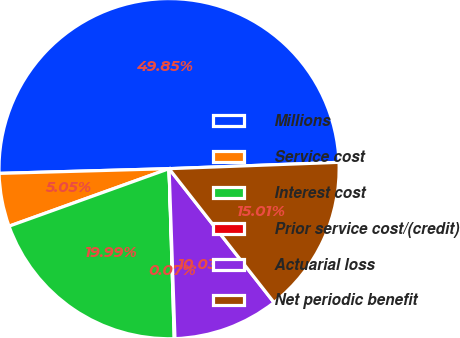Convert chart to OTSL. <chart><loc_0><loc_0><loc_500><loc_500><pie_chart><fcel>Millions<fcel>Service cost<fcel>Interest cost<fcel>Prior service cost/(credit)<fcel>Actuarial loss<fcel>Net periodic benefit<nl><fcel>49.85%<fcel>5.05%<fcel>19.99%<fcel>0.07%<fcel>10.03%<fcel>15.01%<nl></chart> 